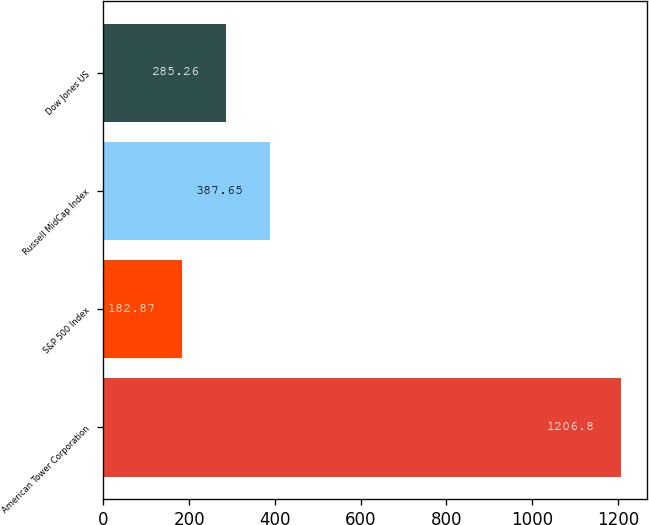Convert chart. <chart><loc_0><loc_0><loc_500><loc_500><bar_chart><fcel>American Tower Corporation<fcel>S&P 500 Index<fcel>Russell MidCap Index<fcel>Dow Jones US<nl><fcel>1206.8<fcel>182.87<fcel>387.65<fcel>285.26<nl></chart> 